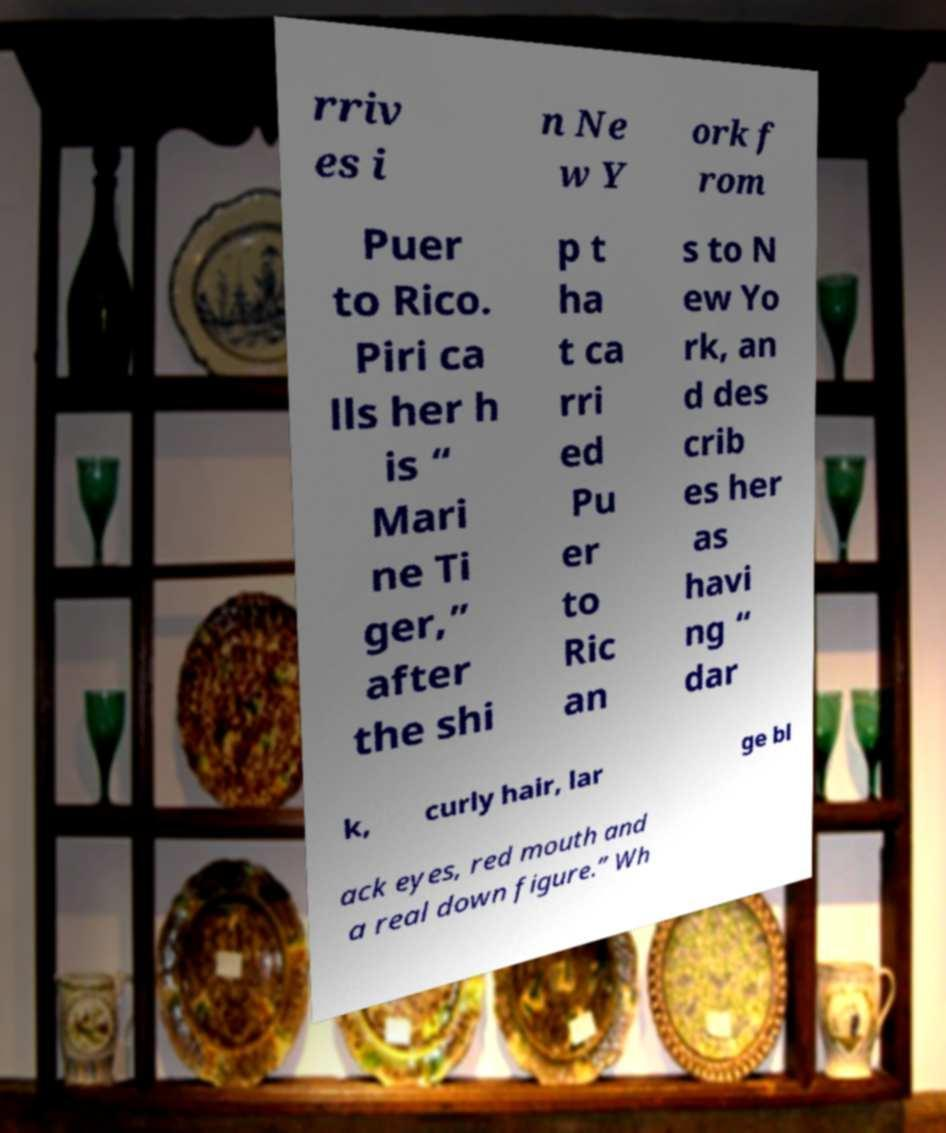Please read and relay the text visible in this image. What does it say? rriv es i n Ne w Y ork f rom Puer to Rico. Piri ca lls her h is “ Mari ne Ti ger,” after the shi p t ha t ca rri ed Pu er to Ric an s to N ew Yo rk, an d des crib es her as havi ng “ dar k, curly hair, lar ge bl ack eyes, red mouth and a real down figure.” Wh 